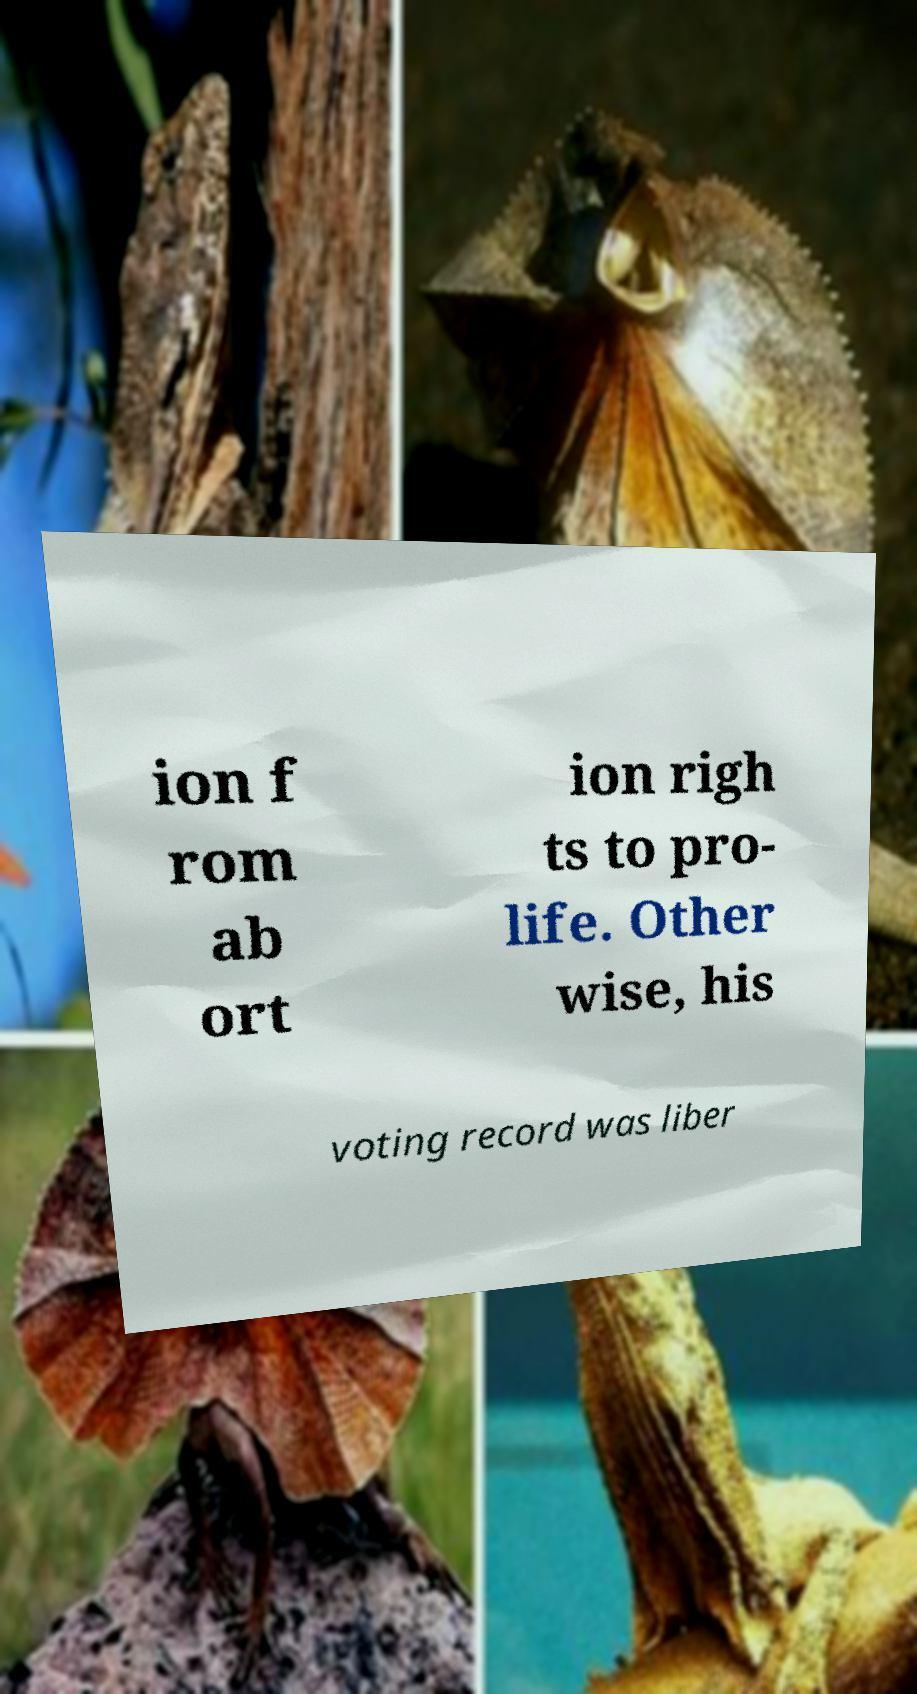Please read and relay the text visible in this image. What does it say? ion f rom ab ort ion righ ts to pro- life. Other wise, his voting record was liber 